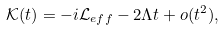<formula> <loc_0><loc_0><loc_500><loc_500>\mathcal { K } ( t ) = - i \mathcal { L } _ { e f f } - 2 \Lambda t + o ( t ^ { 2 } ) ,</formula> 